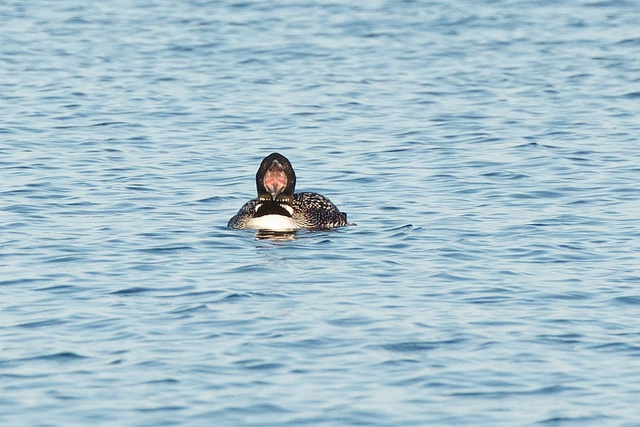Describe the objects in this image and their specific colors. I can see a bird in lightblue, black, gray, and ivory tones in this image. 